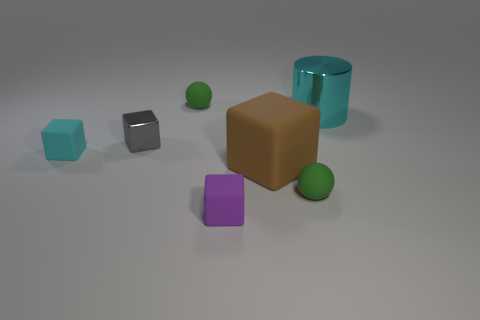Subtract 1 cubes. How many cubes are left? 3 Subtract all cyan matte cubes. How many cubes are left? 3 Add 2 green rubber objects. How many objects exist? 9 Subtract all cyan blocks. How many blocks are left? 3 Subtract all cylinders. How many objects are left? 6 Subtract all blue cubes. Subtract all green balls. How many cubes are left? 4 Add 2 green rubber spheres. How many green rubber spheres are left? 4 Add 7 matte blocks. How many matte blocks exist? 10 Subtract 0 red cubes. How many objects are left? 7 Subtract all small purple objects. Subtract all small red matte spheres. How many objects are left? 6 